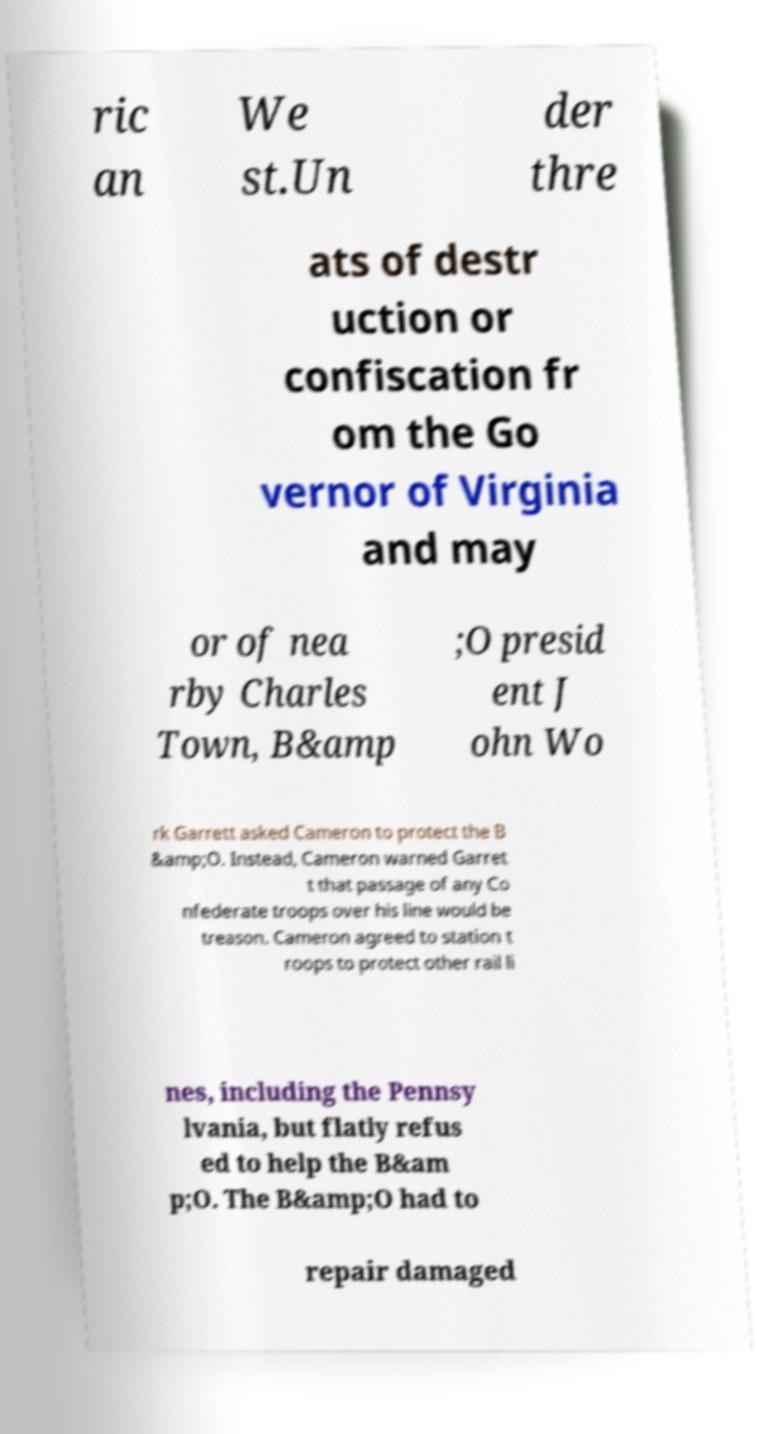Can you read and provide the text displayed in the image?This photo seems to have some interesting text. Can you extract and type it out for me? ric an We st.Un der thre ats of destr uction or confiscation fr om the Go vernor of Virginia and may or of nea rby Charles Town, B&amp ;O presid ent J ohn Wo rk Garrett asked Cameron to protect the B &amp;O. Instead, Cameron warned Garret t that passage of any Co nfederate troops over his line would be treason. Cameron agreed to station t roops to protect other rail li nes, including the Pennsy lvania, but flatly refus ed to help the B&am p;O. The B&amp;O had to repair damaged 